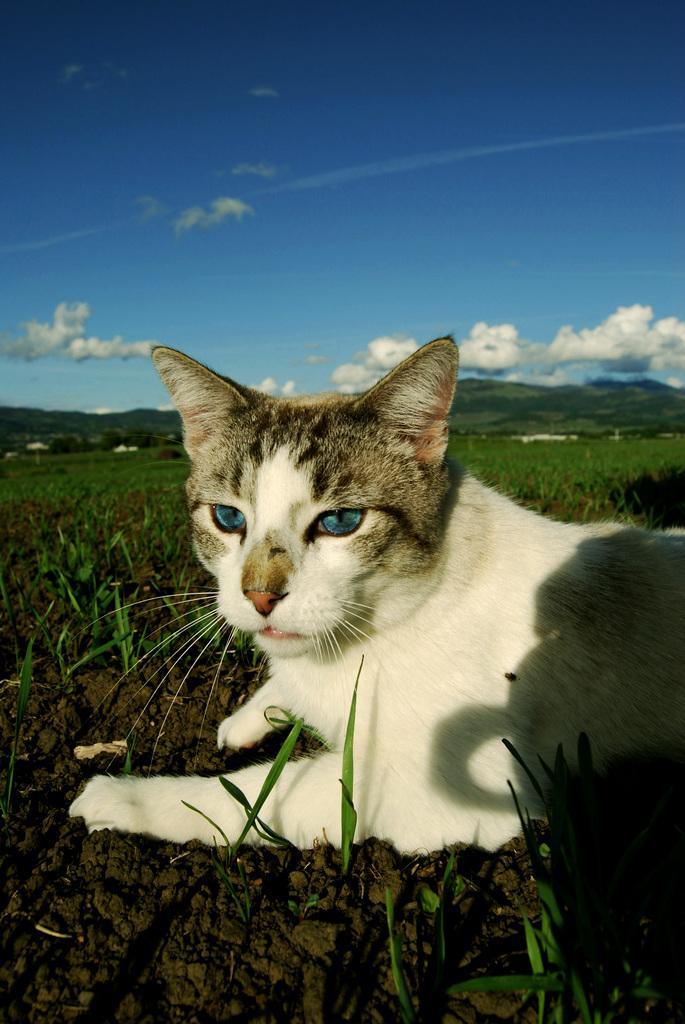Can you describe this image briefly? A cat is sitting on the grass. There are mountains at the back and clouds in the sky. 